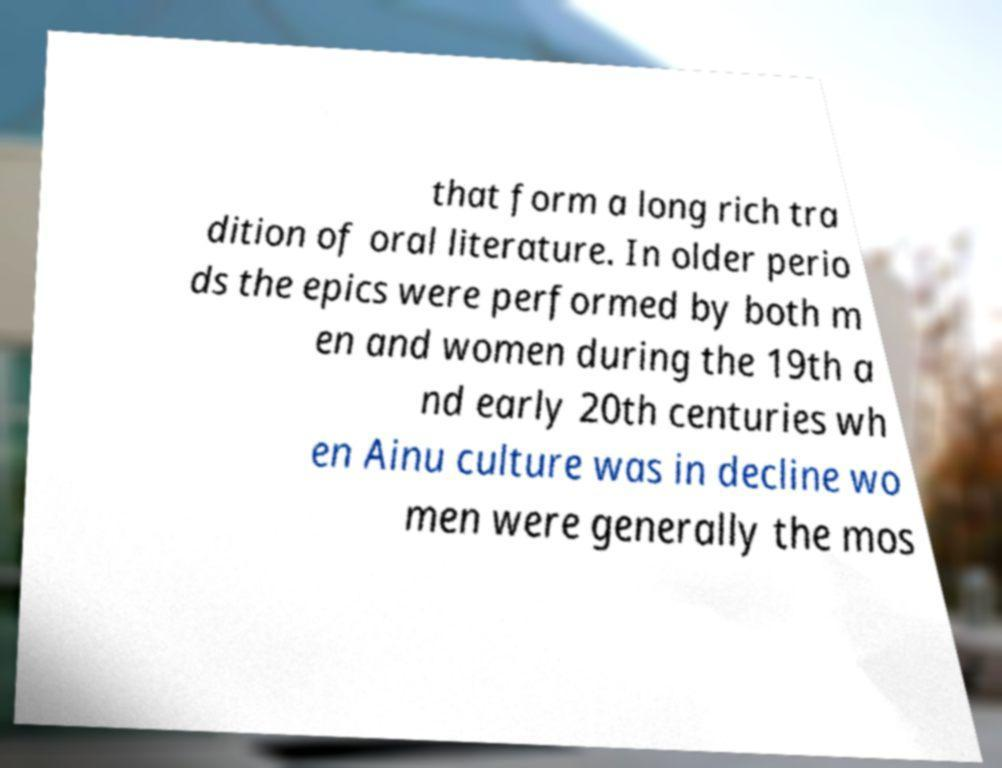There's text embedded in this image that I need extracted. Can you transcribe it verbatim? that form a long rich tra dition of oral literature. In older perio ds the epics were performed by both m en and women during the 19th a nd early 20th centuries wh en Ainu culture was in decline wo men were generally the mos 